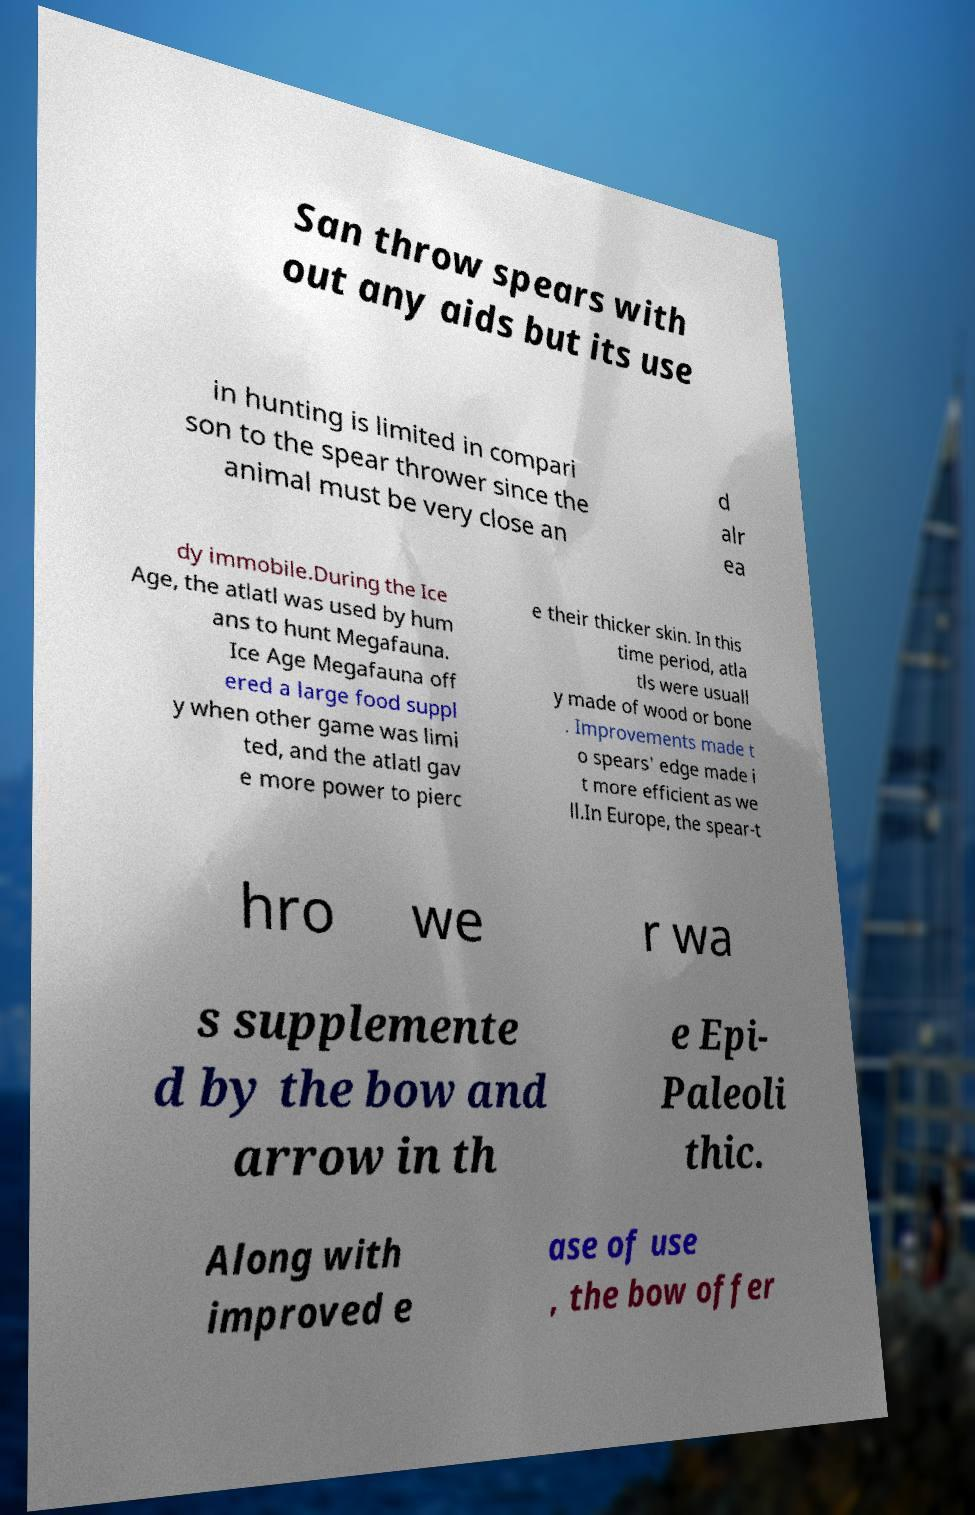Please read and relay the text visible in this image. What does it say? San throw spears with out any aids but its use in hunting is limited in compari son to the spear thrower since the animal must be very close an d alr ea dy immobile.During the Ice Age, the atlatl was used by hum ans to hunt Megafauna. Ice Age Megafauna off ered a large food suppl y when other game was limi ted, and the atlatl gav e more power to pierc e their thicker skin. In this time period, atla tls were usuall y made of wood or bone . Improvements made t o spears' edge made i t more efficient as we ll.In Europe, the spear-t hro we r wa s supplemente d by the bow and arrow in th e Epi- Paleoli thic. Along with improved e ase of use , the bow offer 